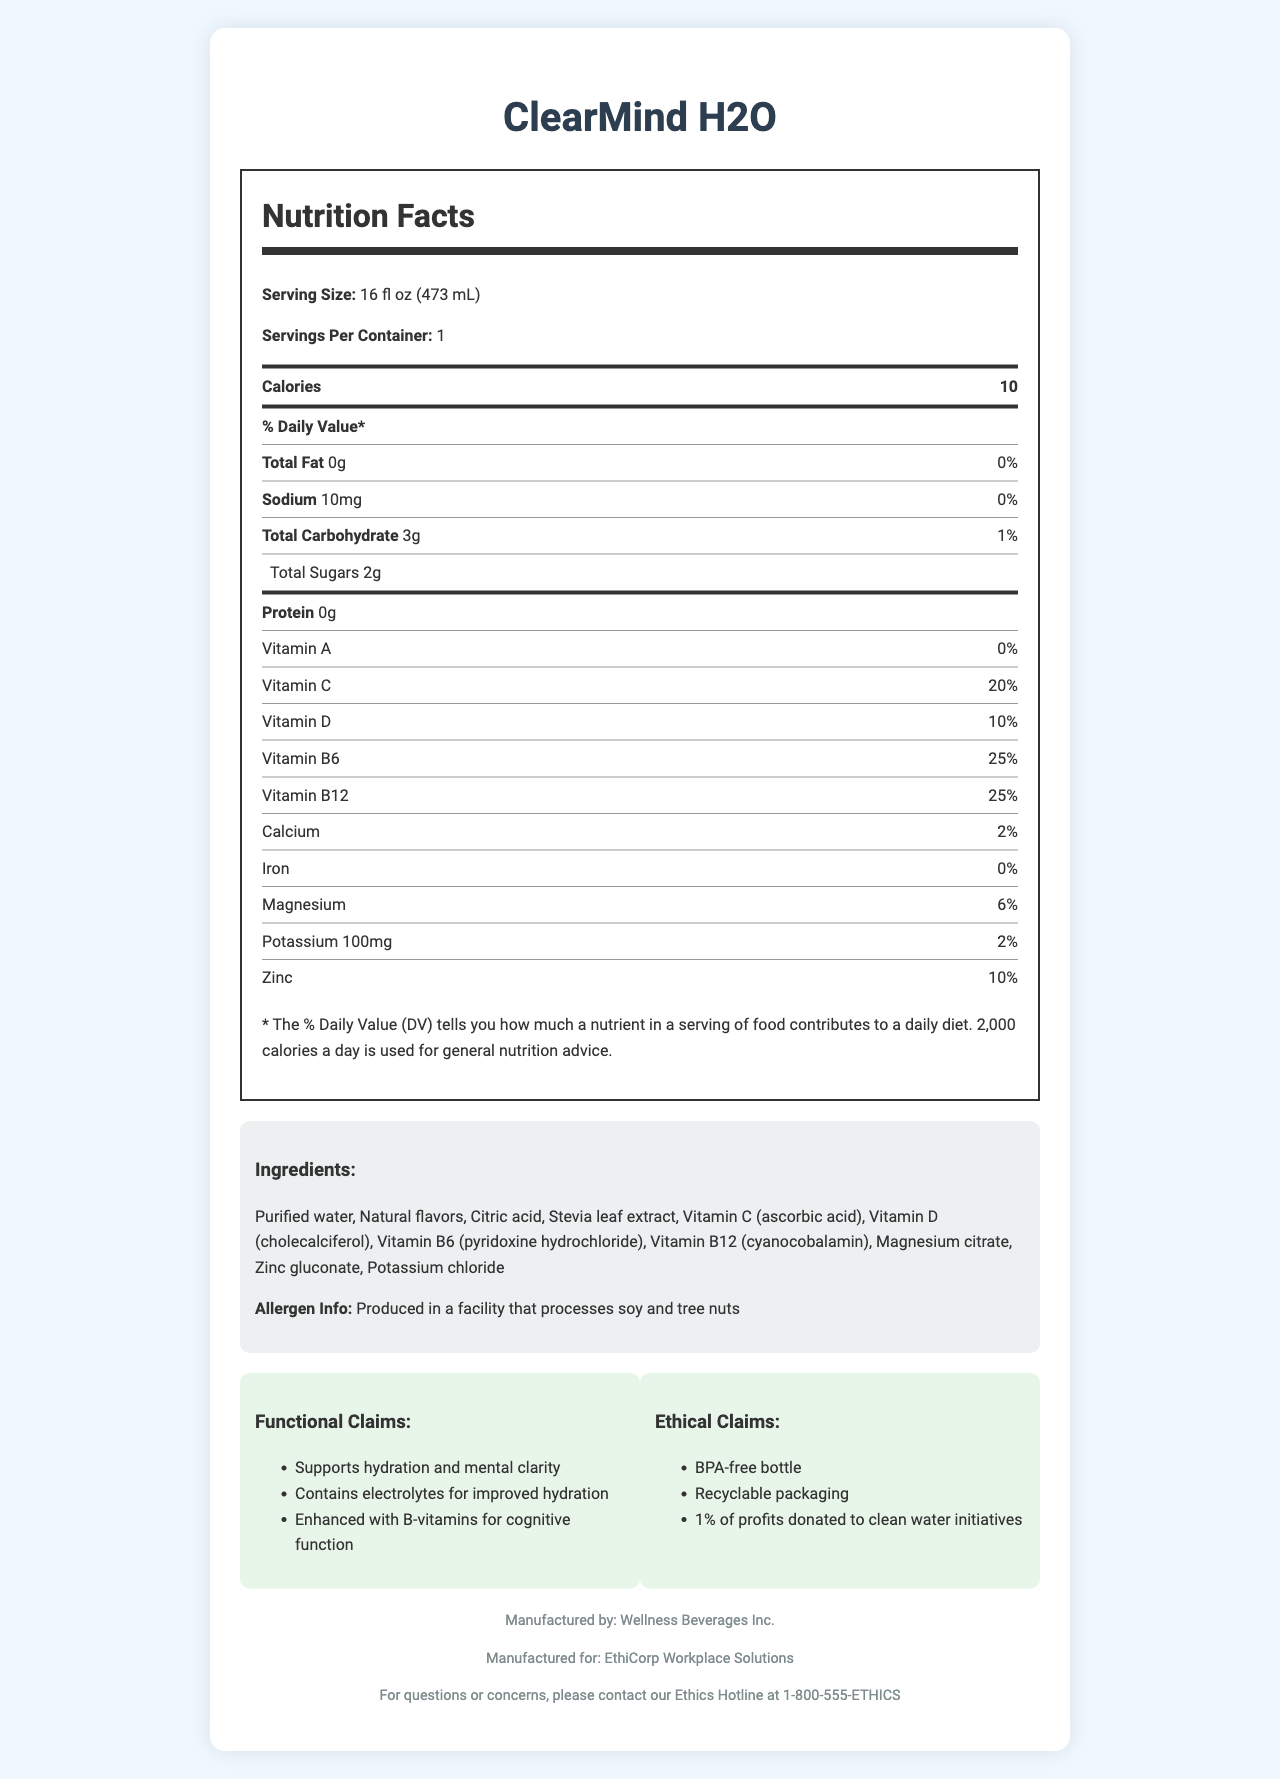what is the serving size of ClearMind H2O? The serving size is listed as "16 fl oz (473 mL)" in the document.
Answer: 16 fl oz (473 mL) How many calories does one serving of ClearMind H2O contain? The document states that there are 10 calories per serving.
Answer: 10 What percentage of the daily value is Vitamin C in ClearMind H2O? The document mentions that the Vitamin C percentage of daily value is 20%.
Answer: 20% What is the amount of sodium in one serving of ClearMind H2O? The sodium content per serving is 10mg, as listed in the document.
Answer: 10mg What are the three main functional claims of ClearMind H2O? The functional claims are listed as: "Supports hydration and mental clarity," "Contains electrolytes for improved hydration," and "Enhanced with B-vitamins for cognitive function."
Answer: Supports hydration and mental clarity; Contains electrolytes for improved hydration; Enhanced with B-vitamins for cognitive function Which company manufactures ClearMind H2O? A. Wellness Beverages Inc. B. EthiCorp Workplace Solutions C. ClearMind Inc. D. Hydration Corp. The document states that ClearMind H2O is manufactured by Wellness Beverages Inc.
Answer: A What amount of potassium does ClearMind H2O contain per serving? A. 50mg B. 75mg C. 100mg D. 150mg The document lists the potassium content per serving as 100mg.
Answer: C Is the bottle of ClearMind H2O BPA-free? "BPA-free bottle" is one of the ethical claims mentioned in the document.
Answer: Yes Summarize the key information presented in the document This summary covers the main points of the document, highlighting the nutritional content, key claims, and ethical considerations.
Answer: The document details the Nutrition Facts, ingredients, functional and ethical claims, allergen information, and contact information for ClearMind H2O. The beverage is designed to support hydration and mental clarity, contains vitamins and minerals, and is manufactured in a BPA-free, recyclable bottle. The product also donates a portion of profits to clean water initiatives. The nutrition label includes specific percentages of daily value for various vitamins and minerals. What is the percentage of daily value for iron in ClearMind H2O? The document lists the daily value percentage for iron as 0%.
Answer: 0% Can ClearMind H2O help with cognitive function? One of the functional claims states that the beverage is "Enhanced with B-vitamins for cognitive function."
Answer: Yes Are there any allergens present in ClearMind H2O? The document states that ClearMind H2O does not contain any allergens but is produced in a facility that processes soy and tree nuts.
Answer: No What is the main purpose of the beverage according to its functional claims? The main functional claim is that it supports hydration and mental clarity.
Answer: Supports hydration and mental clarity Who should I contact for concerns about ClearMind H2O? The document provides a contact number for the Ethics Hotline.
Answer: Ethics Hotline at 1-800-555-ETHICS What type of extract is used as a sweetener in ClearMind H2O? The ingredients list includes Stevia leaf extract as a sweetener.
Answer: Stevia leaf extract When was ClearMind H2O first manufactured? The document does not provide information about the manufacturing date.
Answer: Cannot be determined 